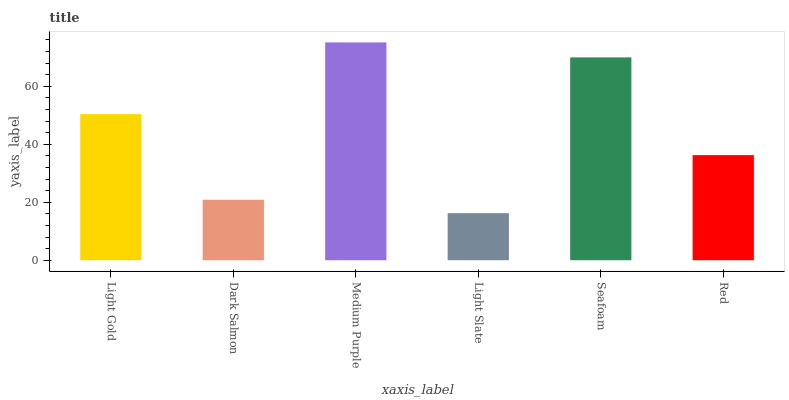Is Light Slate the minimum?
Answer yes or no. Yes. Is Medium Purple the maximum?
Answer yes or no. Yes. Is Dark Salmon the minimum?
Answer yes or no. No. Is Dark Salmon the maximum?
Answer yes or no. No. Is Light Gold greater than Dark Salmon?
Answer yes or no. Yes. Is Dark Salmon less than Light Gold?
Answer yes or no. Yes. Is Dark Salmon greater than Light Gold?
Answer yes or no. No. Is Light Gold less than Dark Salmon?
Answer yes or no. No. Is Light Gold the high median?
Answer yes or no. Yes. Is Red the low median?
Answer yes or no. Yes. Is Light Slate the high median?
Answer yes or no. No. Is Light Gold the low median?
Answer yes or no. No. 